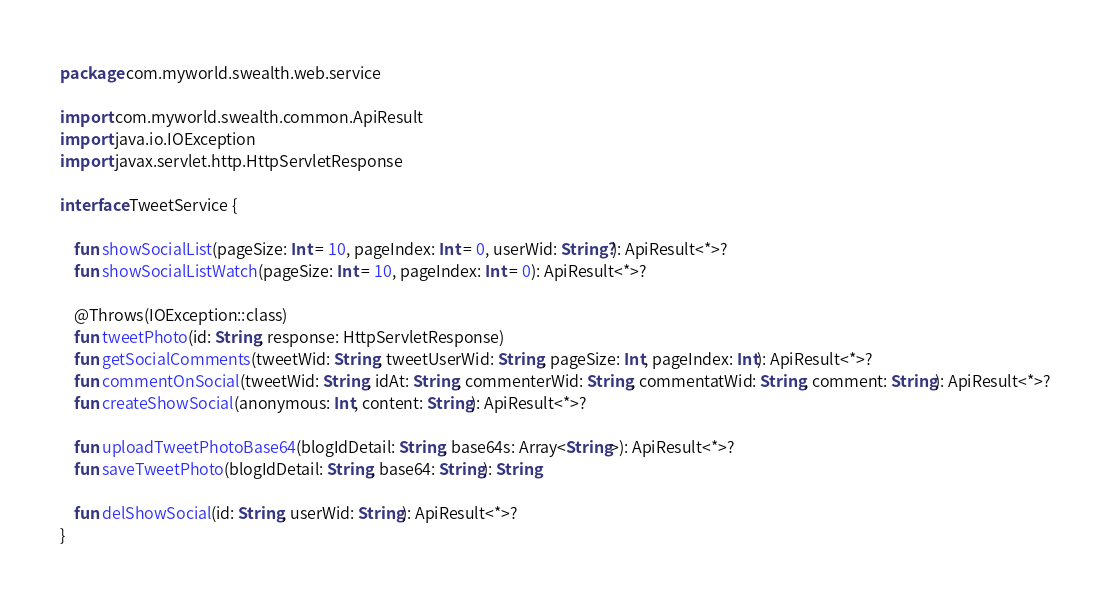<code> <loc_0><loc_0><loc_500><loc_500><_Kotlin_>package com.myworld.swealth.web.service

import com.myworld.swealth.common.ApiResult
import java.io.IOException
import javax.servlet.http.HttpServletResponse

interface TweetService {

    fun showSocialList(pageSize: Int = 10, pageIndex: Int = 0, userWid: String?): ApiResult<*>?
    fun showSocialListWatch(pageSize: Int = 10, pageIndex: Int = 0): ApiResult<*>?

    @Throws(IOException::class)
    fun tweetPhoto(id: String, response: HttpServletResponse)
    fun getSocialComments(tweetWid: String, tweetUserWid: String, pageSize: Int, pageIndex: Int): ApiResult<*>?
    fun commentOnSocial(tweetWid: String, idAt: String, commenterWid: String, commentatWid: String, comment: String): ApiResult<*>?
    fun createShowSocial(anonymous: Int, content: String): ApiResult<*>?

    fun uploadTweetPhotoBase64(blogIdDetail: String, base64s: Array<String>): ApiResult<*>?
    fun saveTweetPhoto(blogIdDetail: String, base64: String): String

    fun delShowSocial(id: String, userWid: String): ApiResult<*>?
}
</code> 